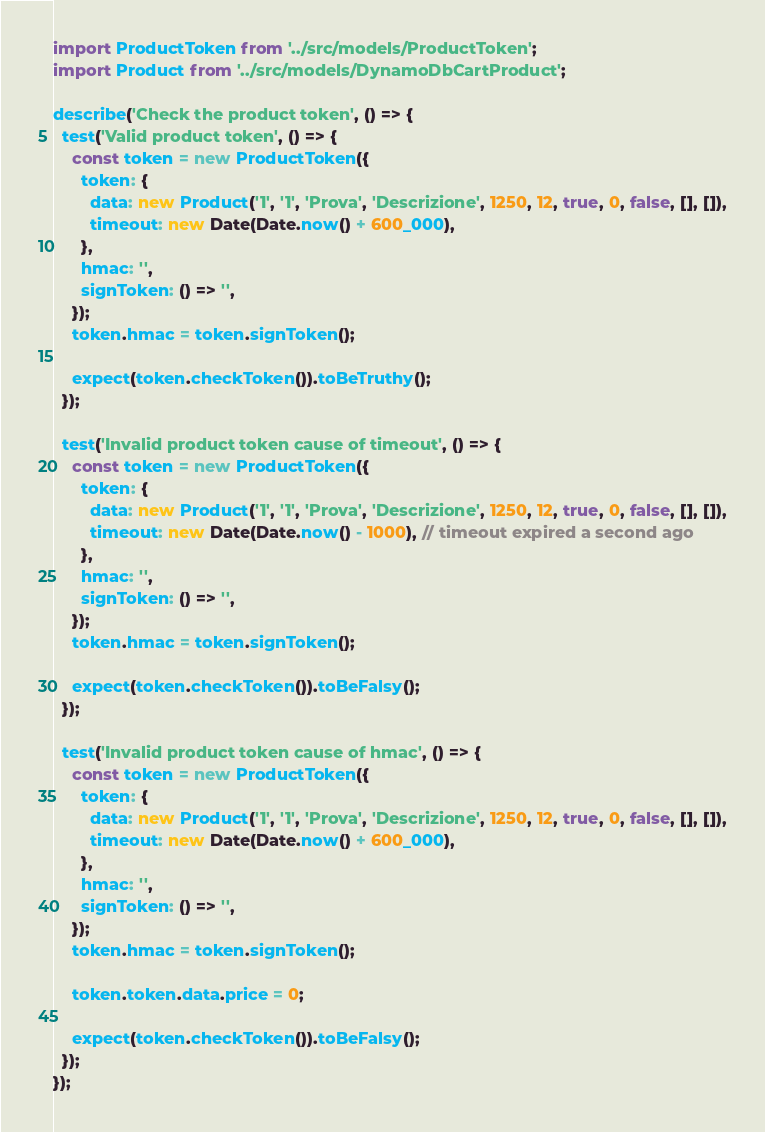<code> <loc_0><loc_0><loc_500><loc_500><_TypeScript_>import ProductToken from '../src/models/ProductToken';
import Product from '../src/models/DynamoDbCartProduct';

describe('Check the product token', () => {
  test('Valid product token', () => {
    const token = new ProductToken({
      token: {
        data: new Product('1', '1', 'Prova', 'Descrizione', 1250, 12, true, 0, false, [], []),
        timeout: new Date(Date.now() + 600_000),
      },
      hmac: '',
      signToken: () => '',
    });
    token.hmac = token.signToken();

    expect(token.checkToken()).toBeTruthy();
  });

  test('Invalid product token cause of timeout', () => {
    const token = new ProductToken({
      token: {
        data: new Product('1', '1', 'Prova', 'Descrizione', 1250, 12, true, 0, false, [], []),
        timeout: new Date(Date.now() - 1000), // timeout expired a second ago
      },
      hmac: '',
      signToken: () => '',
    });
    token.hmac = token.signToken();

    expect(token.checkToken()).toBeFalsy();
  });

  test('Invalid product token cause of hmac', () => {
    const token = new ProductToken({
      token: {
        data: new Product('1', '1', 'Prova', 'Descrizione', 1250, 12, true, 0, false, [], []),
        timeout: new Date(Date.now() + 600_000),
      },
      hmac: '',
      signToken: () => '',
    });
    token.hmac = token.signToken();

    token.token.data.price = 0;

    expect(token.checkToken()).toBeFalsy();
  });
});
</code> 